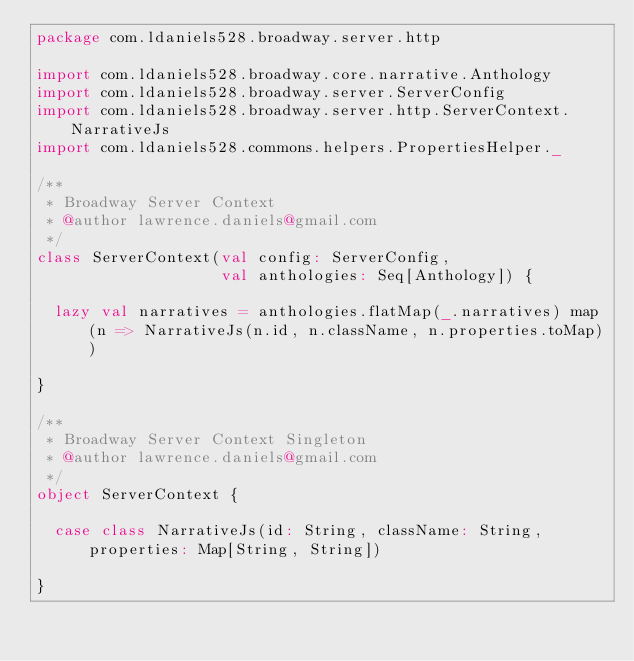Convert code to text. <code><loc_0><loc_0><loc_500><loc_500><_Scala_>package com.ldaniels528.broadway.server.http

import com.ldaniels528.broadway.core.narrative.Anthology
import com.ldaniels528.broadway.server.ServerConfig
import com.ldaniels528.broadway.server.http.ServerContext.NarrativeJs
import com.ldaniels528.commons.helpers.PropertiesHelper._

/**
 * Broadway Server Context
 * @author lawrence.daniels@gmail.com
 */
class ServerContext(val config: ServerConfig,
                    val anthologies: Seq[Anthology]) {

  lazy val narratives = anthologies.flatMap(_.narratives) map (n => NarrativeJs(n.id, n.className, n.properties.toMap))

}

/**
 * Broadway Server Context Singleton
 * @author lawrence.daniels@gmail.com
 */
object ServerContext {

  case class NarrativeJs(id: String, className: String, properties: Map[String, String])

}</code> 